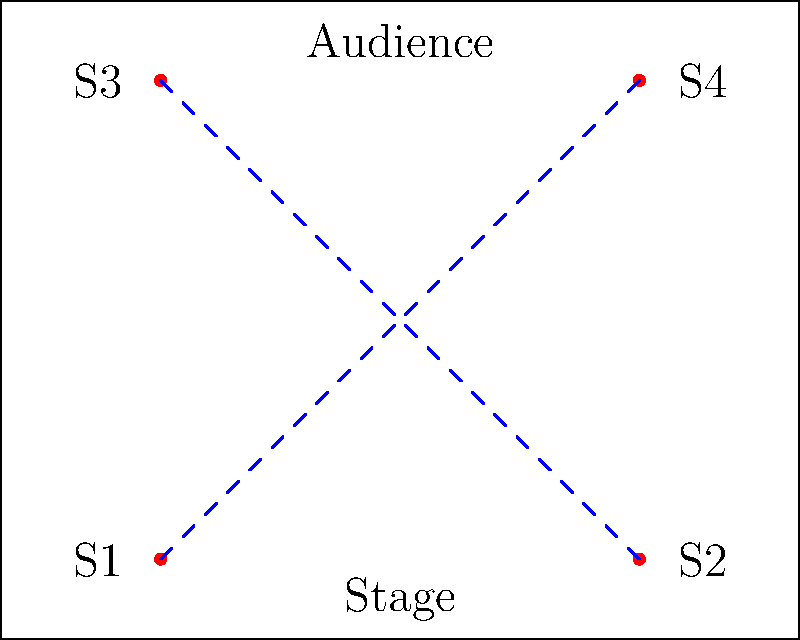In a reality show set, four speakers are placed in the corners of a rectangular room as shown in the diagram. The sound waves from opposite speakers intersect at the center of the room. If the speed of sound in air is 343 m/s and the room is 10 meters wide, what is the time difference (in milliseconds) between when a sound is emitted from speaker S1 and when it reaches the center of the room? To solve this problem, we'll follow these steps:

1. Determine the distance from speaker S1 to the center of the room.
2. Calculate the time it takes for the sound to travel this distance.
3. Convert the time to milliseconds.

Step 1: Distance from S1 to the center
- The room is 10 meters wide.
- S1 is in the corner, so it's 5 meters from the center horizontally.
- The room appears to be 8 meters long (based on the 10:8 ratio in the diagram).
- S1 is 4 meters from the center vertically.
- We can use the Pythagorean theorem to find the diagonal distance:

   $$d = \sqrt{5^2 + 4^2} = \sqrt{25 + 16} = \sqrt{41} \approx 6.40 \text{ meters}$$

Step 2: Time for sound to travel
- Using the formula: $\text{time} = \frac{\text{distance}}{\text{speed}}$
- $$t = \frac{6.40 \text{ m}}{343 \text{ m/s}} \approx 0.01867 \text{ seconds}$$

Step 3: Convert to milliseconds
- $$0.01867 \text{ seconds} \times 1000 = 18.67 \text{ milliseconds}$$

Therefore, it takes approximately 18.67 milliseconds for the sound to travel from S1 to the center of the room.
Answer: 18.67 ms 